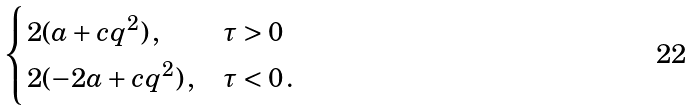<formula> <loc_0><loc_0><loc_500><loc_500>\begin{cases} 2 ( a + c q ^ { 2 } ) \, , & \tau > 0 \\ 2 ( - 2 a + c q ^ { 2 } ) \, , & \tau < 0 \, . \end{cases}</formula> 